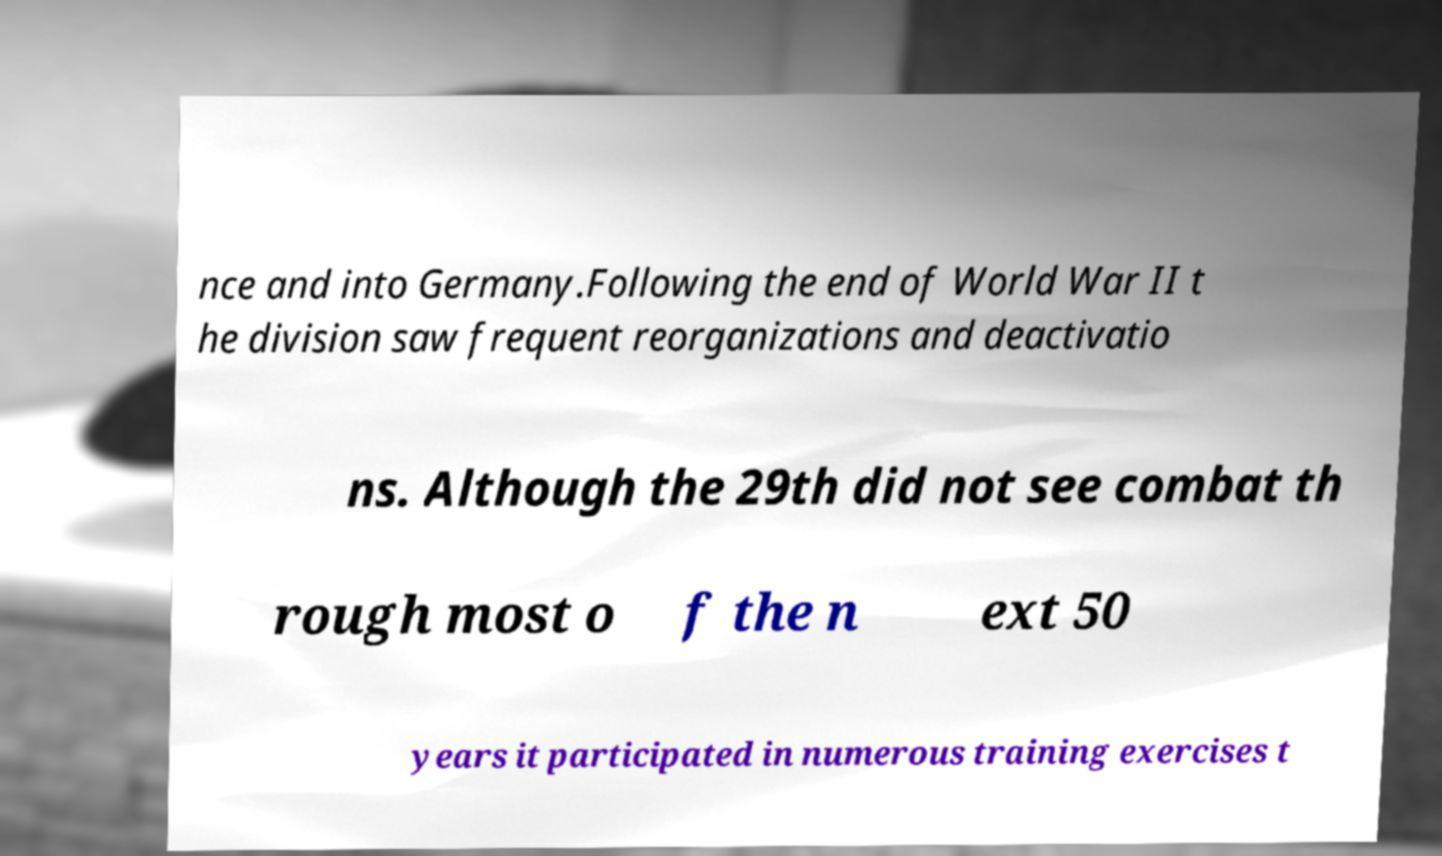Could you assist in decoding the text presented in this image and type it out clearly? nce and into Germany.Following the end of World War II t he division saw frequent reorganizations and deactivatio ns. Although the 29th did not see combat th rough most o f the n ext 50 years it participated in numerous training exercises t 